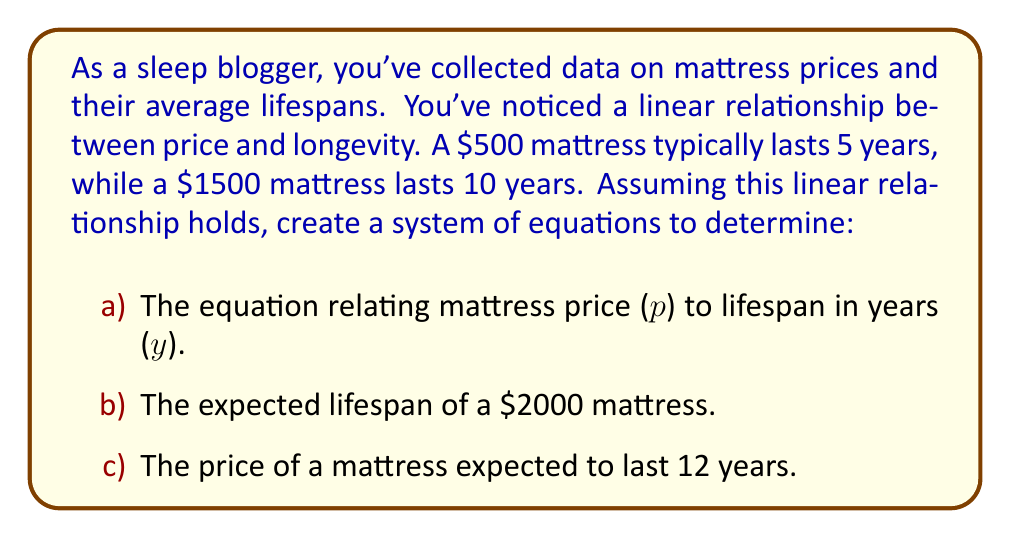Can you solve this math problem? Let's approach this step-by-step:

1) First, we need to set up our system of equations. We know two points on our line:
   ($500, 5) and ($1500, 10)

2) The general form of a linear equation is $y = mx + b$, where $m$ is the slope and $b$ is the y-intercept. In our case, $p$ represents price (x-axis) and $y$ represents lifespan in years (y-axis).

3) We can calculate the slope:
   $m = \frac{y_2 - y_1}{x_2 - x_1} = \frac{10 - 5}{1500 - 500} = \frac{5}{1000} = 0.005$

4) Now we can use either point to find $b$. Let's use (500, 5):
   $5 = 0.005(500) + b$
   $5 = 2.5 + b$
   $b = 2.5$

5) Therefore, our equation is:
   $y = 0.005p + 2.5$

6) To find the lifespan of a $2000 mattress, we substitute $p = 2000$:
   $y = 0.005(2000) + 2.5 = 10 + 2.5 = 12.5$ years

7) To find the price of a mattress that lasts 12 years, we solve:
   $12 = 0.005p + 2.5$
   $9.5 = 0.005p$
   $p = 9.5 / 0.005 = 1900$

Therefore, a mattress expected to last 12 years would cost $1900.
Answer: a) $y = 0.005p + 2.5$, where $y$ is the lifespan in years and $p$ is the price in dollars.
b) A $2000 mattress is expected to last 12.5 years.
c) A mattress expected to last 12 years would cost $1900. 